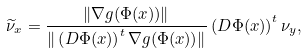Convert formula to latex. <formula><loc_0><loc_0><loc_500><loc_500>\widetilde { \nu } _ { x } = \frac { \| \nabla g ( \Phi ( x ) ) \| } { \| \left ( D \Phi ( x ) \right ) ^ { t } \nabla g ( \Phi ( x ) ) \| } \left ( D \Phi ( x ) \right ) ^ { t } \nu _ { y } ,</formula> 